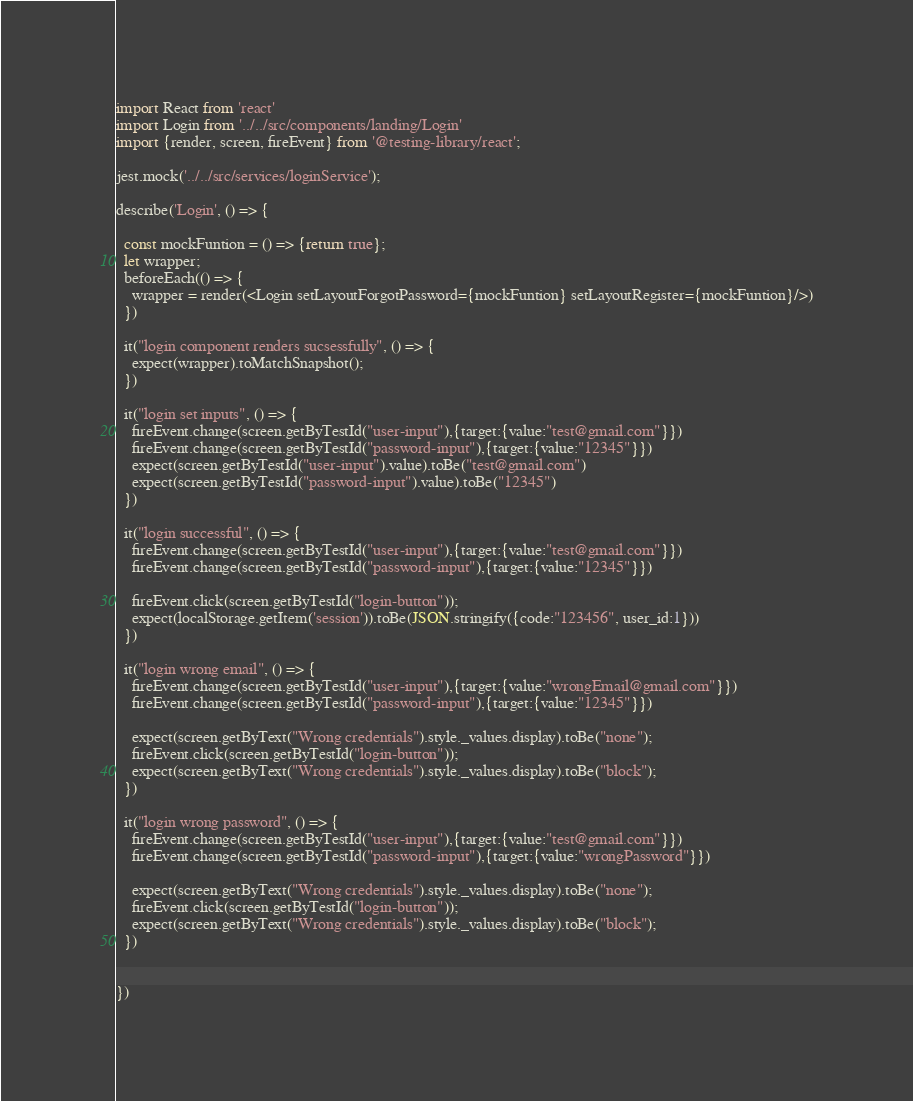Convert code to text. <code><loc_0><loc_0><loc_500><loc_500><_JavaScript_>import React from 'react'
import Login from '../../src/components/landing/Login'
import {render, screen, fireEvent} from '@testing-library/react';

jest.mock('../../src/services/loginService');

describe('Login', () => {

  const mockFuntion = () => {return true};
  let wrapper;
  beforeEach(() => {
    wrapper = render(<Login setLayoutForgotPassword={mockFuntion} setLayoutRegister={mockFuntion}/>)
  })

  it("login component renders sucsessfully", () => {
    expect(wrapper).toMatchSnapshot();
  })

  it("login set inputs", () => {
    fireEvent.change(screen.getByTestId("user-input"),{target:{value:"test@gmail.com"}})
    fireEvent.change(screen.getByTestId("password-input"),{target:{value:"12345"}})
    expect(screen.getByTestId("user-input").value).toBe("test@gmail.com")
    expect(screen.getByTestId("password-input").value).toBe("12345")
  })

  it("login successful", () => {
    fireEvent.change(screen.getByTestId("user-input"),{target:{value:"test@gmail.com"}})
    fireEvent.change(screen.getByTestId("password-input"),{target:{value:"12345"}})
    
    fireEvent.click(screen.getByTestId("login-button"));
    expect(localStorage.getItem('session')).toBe(JSON.stringify({code:"123456", user_id:1}))
  })

  it("login wrong email", () => {
    fireEvent.change(screen.getByTestId("user-input"),{target:{value:"wrongEmail@gmail.com"}})
    fireEvent.change(screen.getByTestId("password-input"),{target:{value:"12345"}})
    
    expect(screen.getByText("Wrong credentials").style._values.display).toBe("none");
    fireEvent.click(screen.getByTestId("login-button"));
    expect(screen.getByText("Wrong credentials").style._values.display).toBe("block");
  })

  it("login wrong password", () => {
    fireEvent.change(screen.getByTestId("user-input"),{target:{value:"test@gmail.com"}})
    fireEvent.change(screen.getByTestId("password-input"),{target:{value:"wrongPassword"}})
    
    expect(screen.getByText("Wrong credentials").style._values.display).toBe("none");
    fireEvent.click(screen.getByTestId("login-button"));
    expect(screen.getByText("Wrong credentials").style._values.display).toBe("block");
  })


})
</code> 